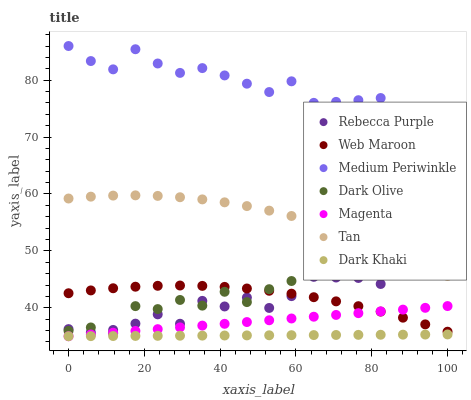Does Dark Khaki have the minimum area under the curve?
Answer yes or no. Yes. Does Medium Periwinkle have the maximum area under the curve?
Answer yes or no. Yes. Does Dark Olive have the minimum area under the curve?
Answer yes or no. No. Does Dark Olive have the maximum area under the curve?
Answer yes or no. No. Is Magenta the smoothest?
Answer yes or no. Yes. Is Dark Olive the roughest?
Answer yes or no. Yes. Is Medium Periwinkle the smoothest?
Answer yes or no. No. Is Medium Periwinkle the roughest?
Answer yes or no. No. Does Dark Khaki have the lowest value?
Answer yes or no. Yes. Does Dark Olive have the lowest value?
Answer yes or no. No. Does Medium Periwinkle have the highest value?
Answer yes or no. Yes. Does Dark Olive have the highest value?
Answer yes or no. No. Is Dark Olive less than Medium Periwinkle?
Answer yes or no. Yes. Is Rebecca Purple greater than Dark Khaki?
Answer yes or no. Yes. Does Magenta intersect Web Maroon?
Answer yes or no. Yes. Is Magenta less than Web Maroon?
Answer yes or no. No. Is Magenta greater than Web Maroon?
Answer yes or no. No. Does Dark Olive intersect Medium Periwinkle?
Answer yes or no. No. 